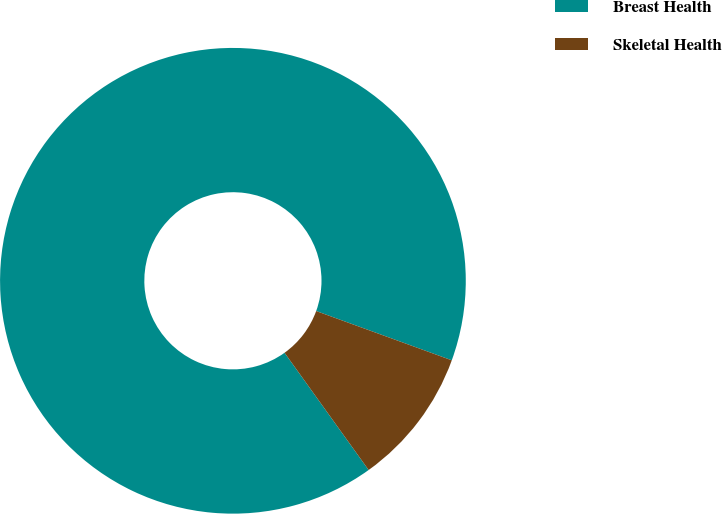Convert chart. <chart><loc_0><loc_0><loc_500><loc_500><pie_chart><fcel>Breast Health<fcel>Skeletal Health<nl><fcel>90.45%<fcel>9.55%<nl></chart> 